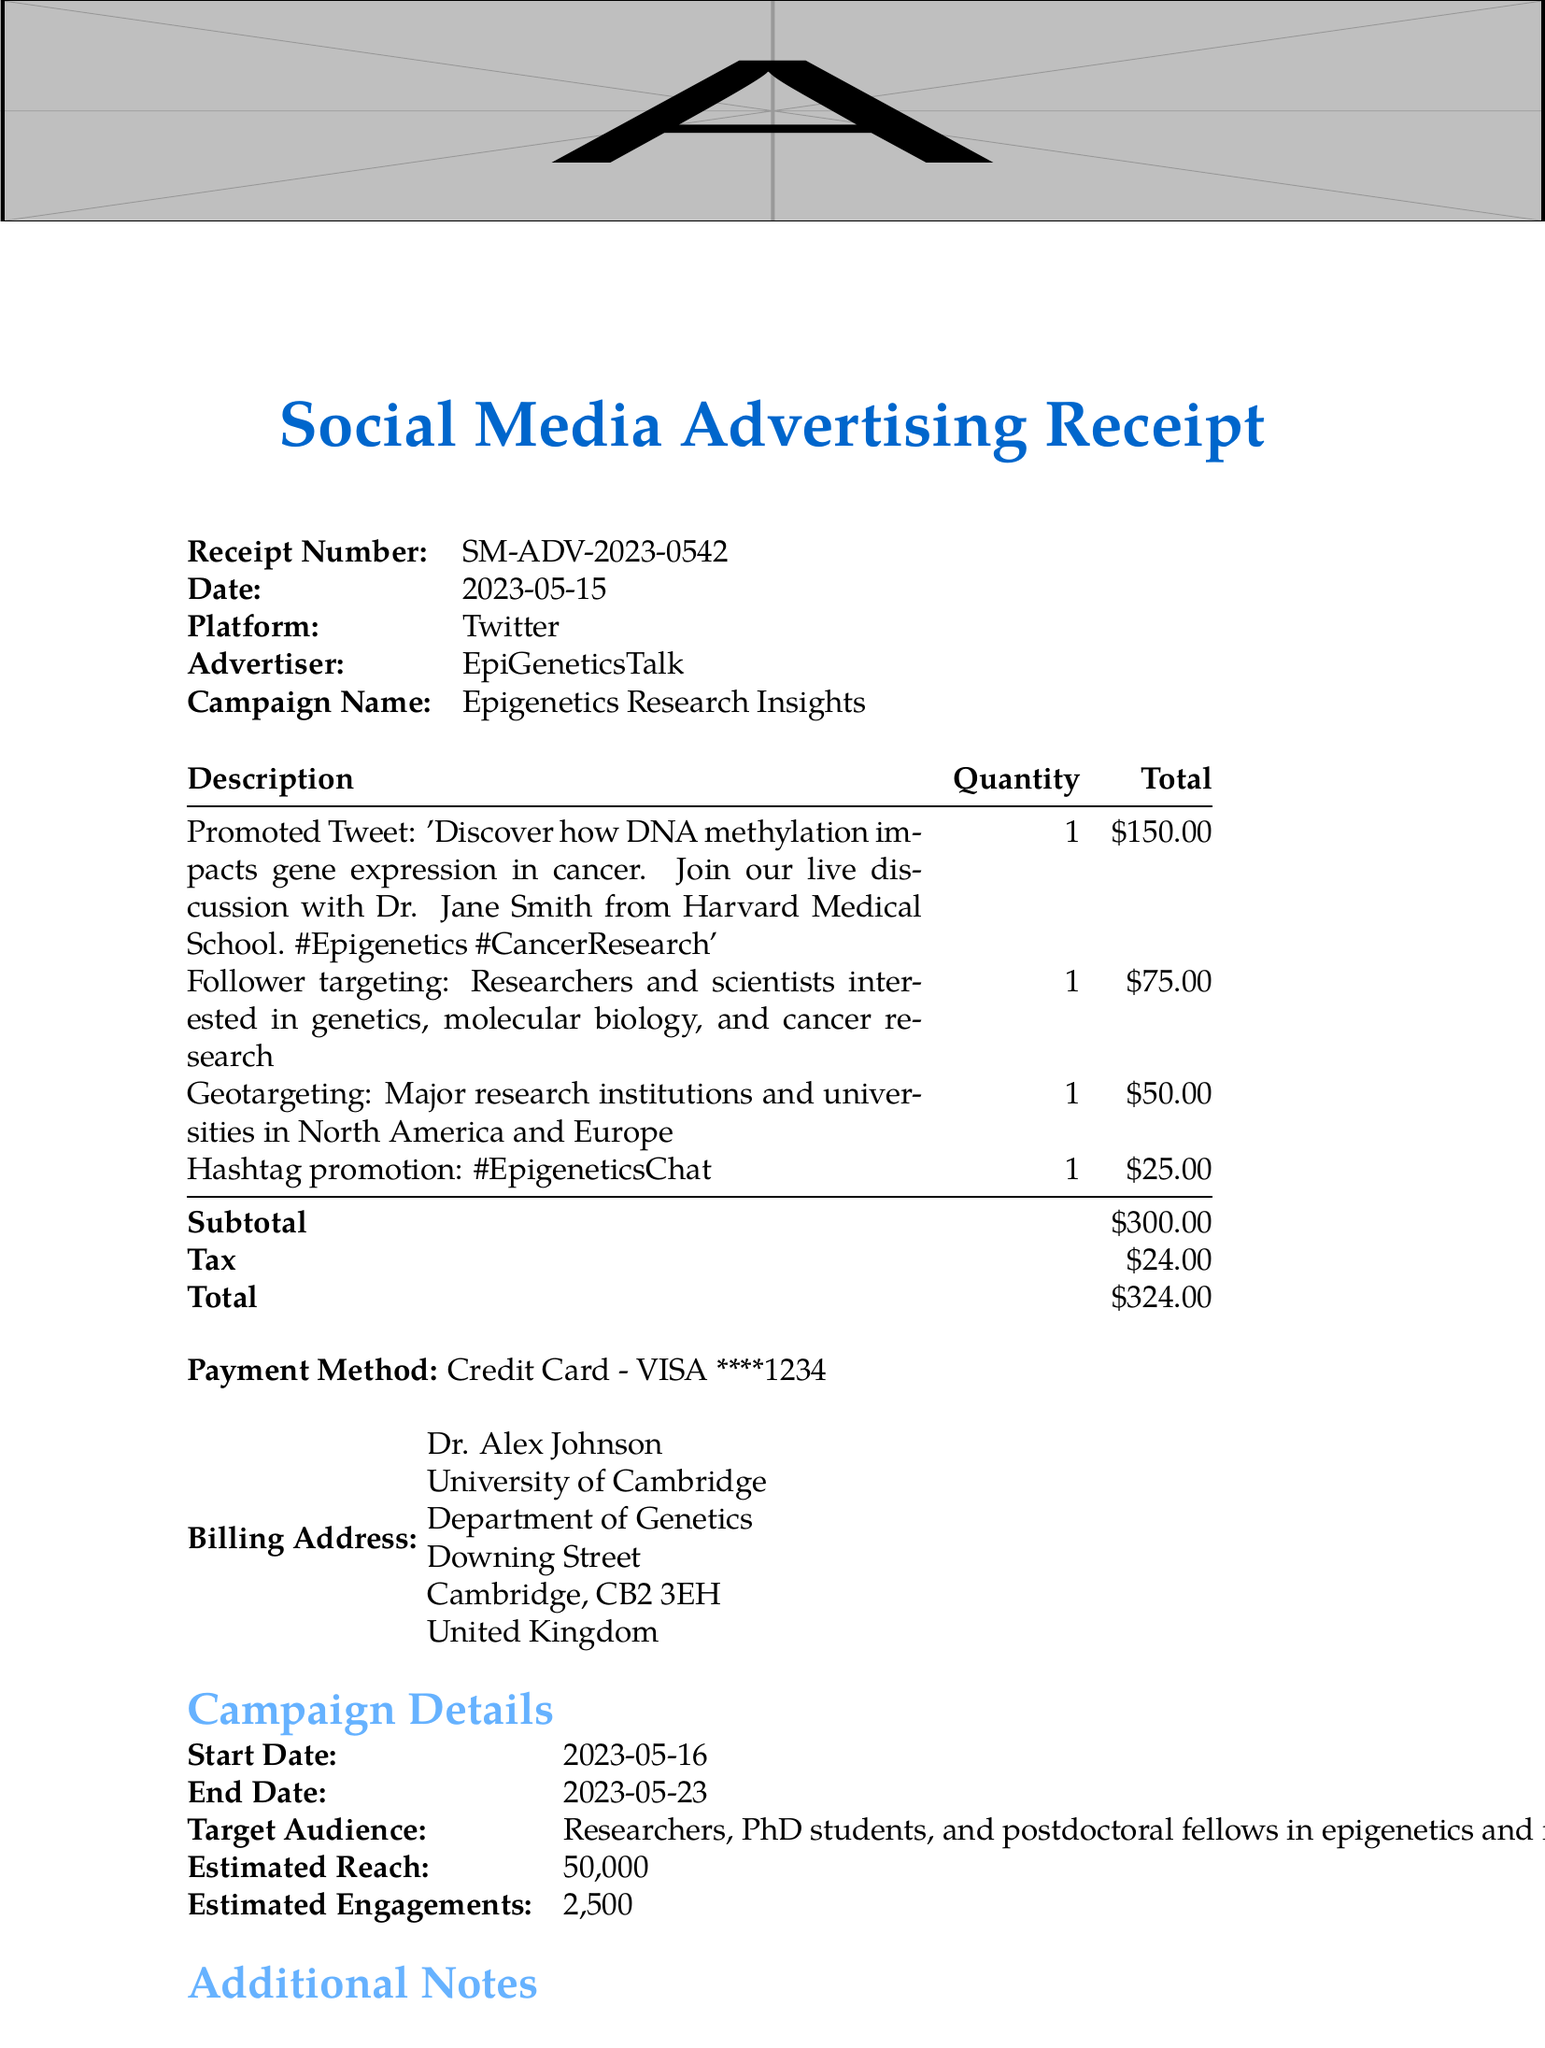What is the receipt number? The receipt number is specified at the top of the document, identifying the transaction.
Answer: SM-ADV-2023-0542 What is the date of the receipt? The date of the receipt indicates when the advertisement was purchased.
Answer: 2023-05-15 What is the total cost of the advertising campaign? The total cost is the sum of the subtotal and tax, reflecting the overall expense of the campaign.
Answer: 324.00 Who is the advertiser for this campaign? The advertiser's name is listed prominently in the receipt details.
Answer: EpiGeneticsTalk What is the campaign name? The campaign name is used to identify the specific advertising effort.
Answer: Epigenetics Research Insights How many items were included in the campaign? The number of items corresponds to the list detailing advertisement components.
Answer: 4 What is the estimated reach of the campaign? The estimated reach is an indication of how many people the campaign is expected to engage.
Answer: 50,000 What is the target audience? The target audience is described to specify the demographic the campaign aims to engage.
Answer: Researchers, PhD students, and postdoctoral fellows in epigenetics and related fields What payment method was used? The payment method is specified to indicate how the transaction was processed.
Answer: Credit Card - VISA ****1234 